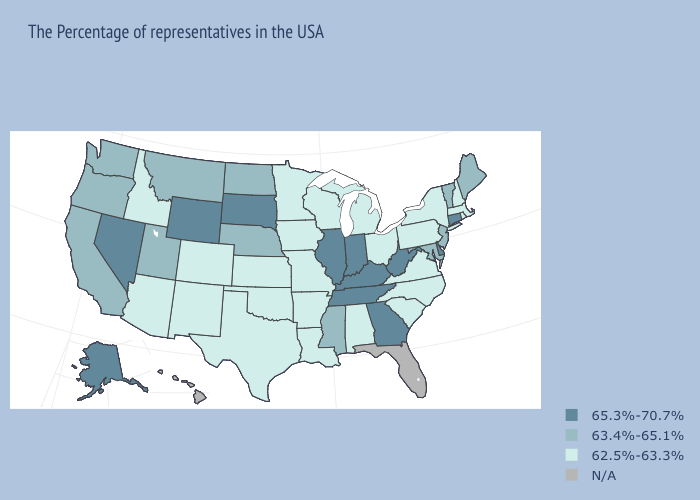Does Connecticut have the highest value in the Northeast?
Write a very short answer. Yes. Does the first symbol in the legend represent the smallest category?
Concise answer only. No. Among the states that border Wisconsin , does Minnesota have the highest value?
Keep it brief. No. Name the states that have a value in the range 65.3%-70.7%?
Write a very short answer. Connecticut, Delaware, West Virginia, Georgia, Kentucky, Indiana, Tennessee, Illinois, South Dakota, Wyoming, Nevada, Alaska. Which states have the highest value in the USA?
Be succinct. Connecticut, Delaware, West Virginia, Georgia, Kentucky, Indiana, Tennessee, Illinois, South Dakota, Wyoming, Nevada, Alaska. What is the highest value in states that border South Carolina?
Be succinct. 65.3%-70.7%. What is the highest value in states that border Connecticut?
Answer briefly. 62.5%-63.3%. Name the states that have a value in the range 65.3%-70.7%?
Give a very brief answer. Connecticut, Delaware, West Virginia, Georgia, Kentucky, Indiana, Tennessee, Illinois, South Dakota, Wyoming, Nevada, Alaska. Among the states that border New Jersey , which have the lowest value?
Write a very short answer. New York, Pennsylvania. Among the states that border Florida , does Alabama have the highest value?
Quick response, please. No. Does Vermont have the lowest value in the Northeast?
Keep it brief. No. What is the highest value in the USA?
Write a very short answer. 65.3%-70.7%. Does the first symbol in the legend represent the smallest category?
Answer briefly. No. Name the states that have a value in the range 63.4%-65.1%?
Give a very brief answer. Maine, Vermont, New Jersey, Maryland, Mississippi, Nebraska, North Dakota, Utah, Montana, California, Washington, Oregon. How many symbols are there in the legend?
Answer briefly. 4. 